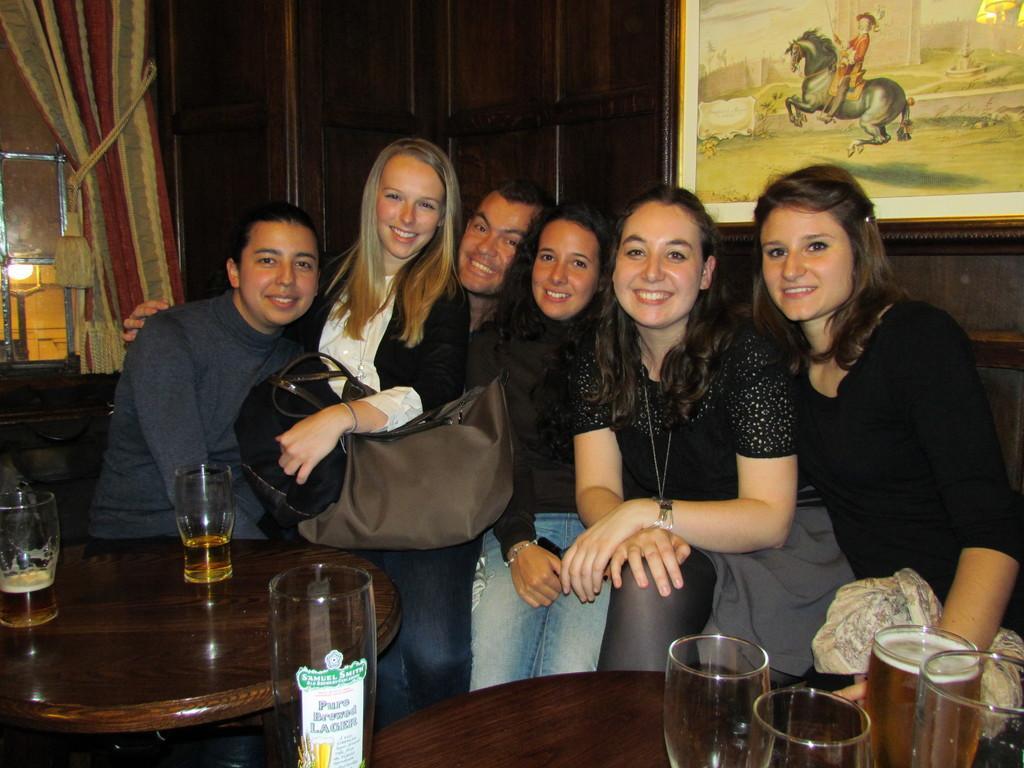In one or two sentences, can you explain what this image depicts? On the background we can see a photo frame , curtain and a light. In Front of the picture we cans few persons giving a nice pose to the camera and they all hold a beautiful smile on their faces. Here we can see a table and on the table we can see drinking glasses. 